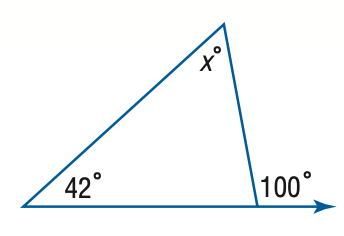Answer the mathemtical geometry problem and directly provide the correct option letter.
Question: Find x.
Choices: A: 42 B: 48 C: 52 D: 58 D 